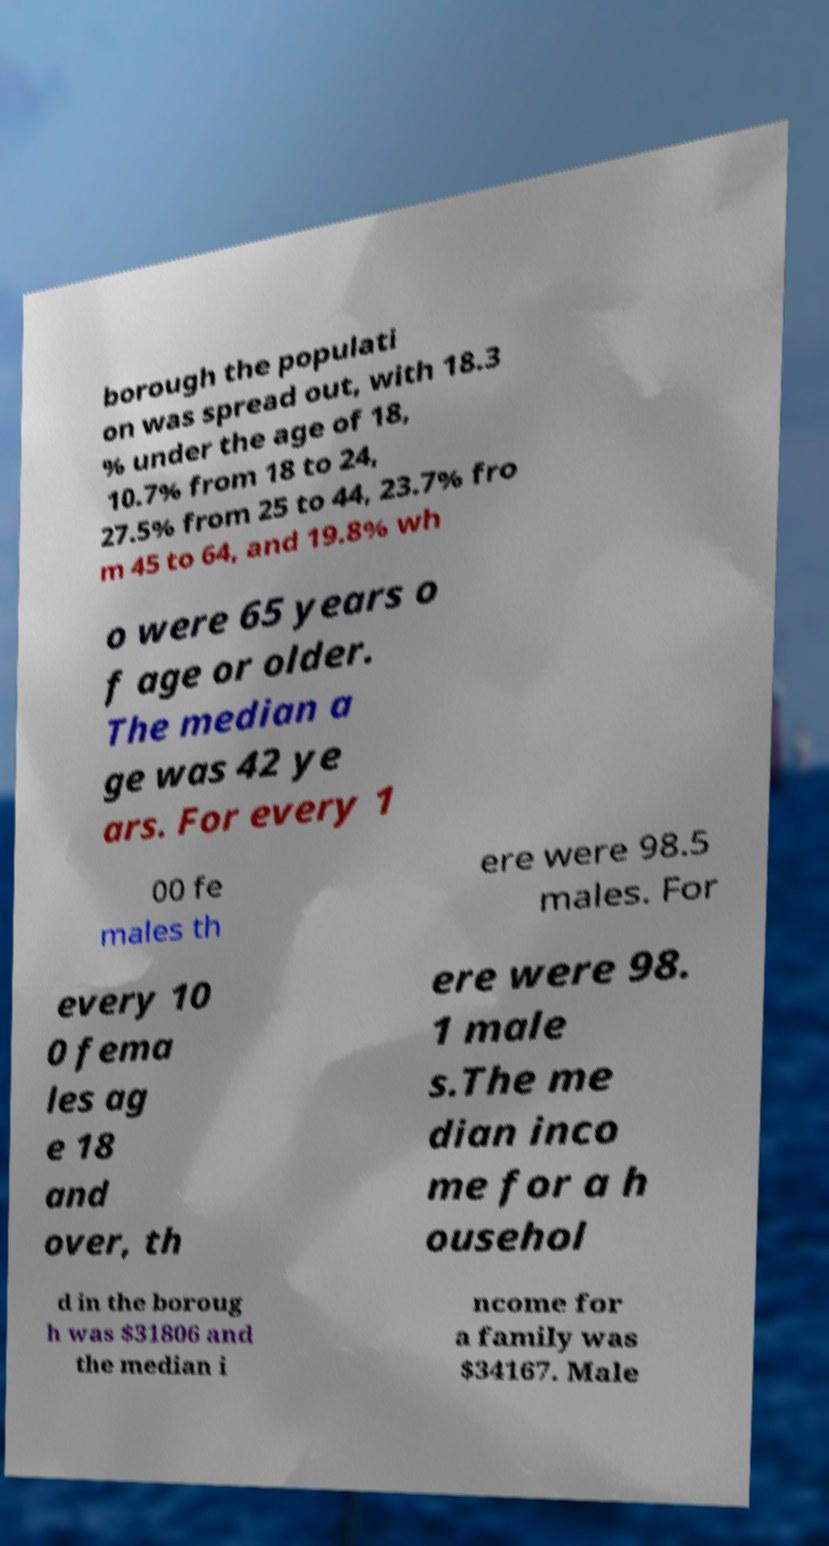Can you accurately transcribe the text from the provided image for me? borough the populati on was spread out, with 18.3 % under the age of 18, 10.7% from 18 to 24, 27.5% from 25 to 44, 23.7% fro m 45 to 64, and 19.8% wh o were 65 years o f age or older. The median a ge was 42 ye ars. For every 1 00 fe males th ere were 98.5 males. For every 10 0 fema les ag e 18 and over, th ere were 98. 1 male s.The me dian inco me for a h ousehol d in the boroug h was $31806 and the median i ncome for a family was $34167. Male 